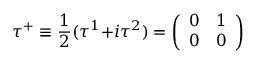<formula> <loc_0><loc_0><loc_500><loc_500>\tau ^ { + } \equiv \frac { 1 } { 2 } ( \tau ^ { 1 } { + } i \tau ^ { 2 } ) = { \left ( \begin{array} { l l } { 0 } & { 1 } \\ { 0 } & { 0 } \end{array} \right ) }</formula> 